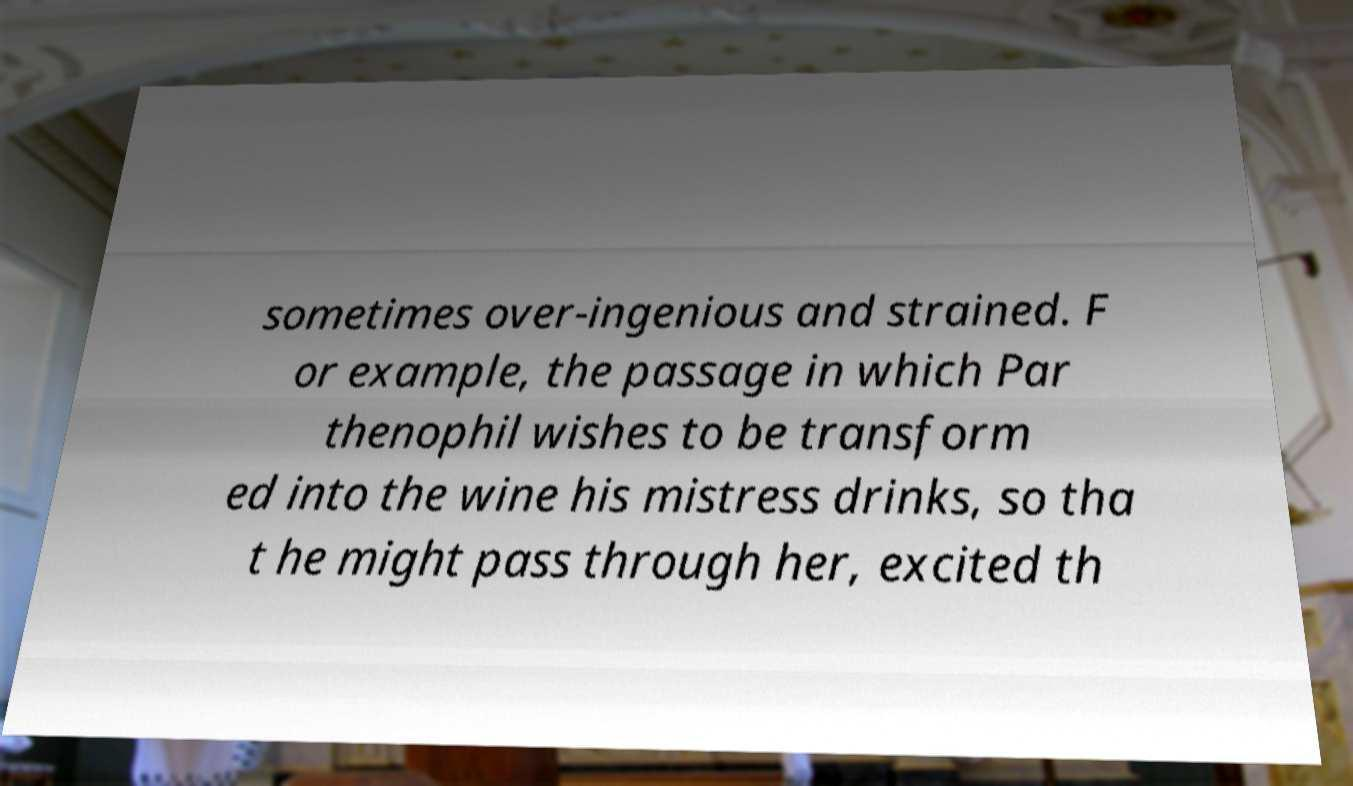For documentation purposes, I need the text within this image transcribed. Could you provide that? sometimes over-ingenious and strained. F or example, the passage in which Par thenophil wishes to be transform ed into the wine his mistress drinks, so tha t he might pass through her, excited th 